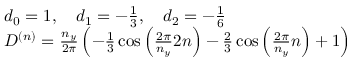Convert formula to latex. <formula><loc_0><loc_0><loc_500><loc_500>\begin{array} { r l } & { d _ { 0 } = 1 , \quad d _ { 1 } = - \frac { 1 } { 3 } , \quad d _ { 2 } = - \frac { 1 } { 6 } } \\ & { D ^ { ( n ) } = \frac { n _ { y } } { 2 \pi } \left ( - \frac { 1 } { 3 } \cos \left ( \frac { 2 \pi } { n _ { y } } 2 n \right ) - \frac { 2 } { 3 } \cos \left ( \frac { 2 \pi } { n _ { y } } n \right ) + 1 \right ) } \end{array}</formula> 